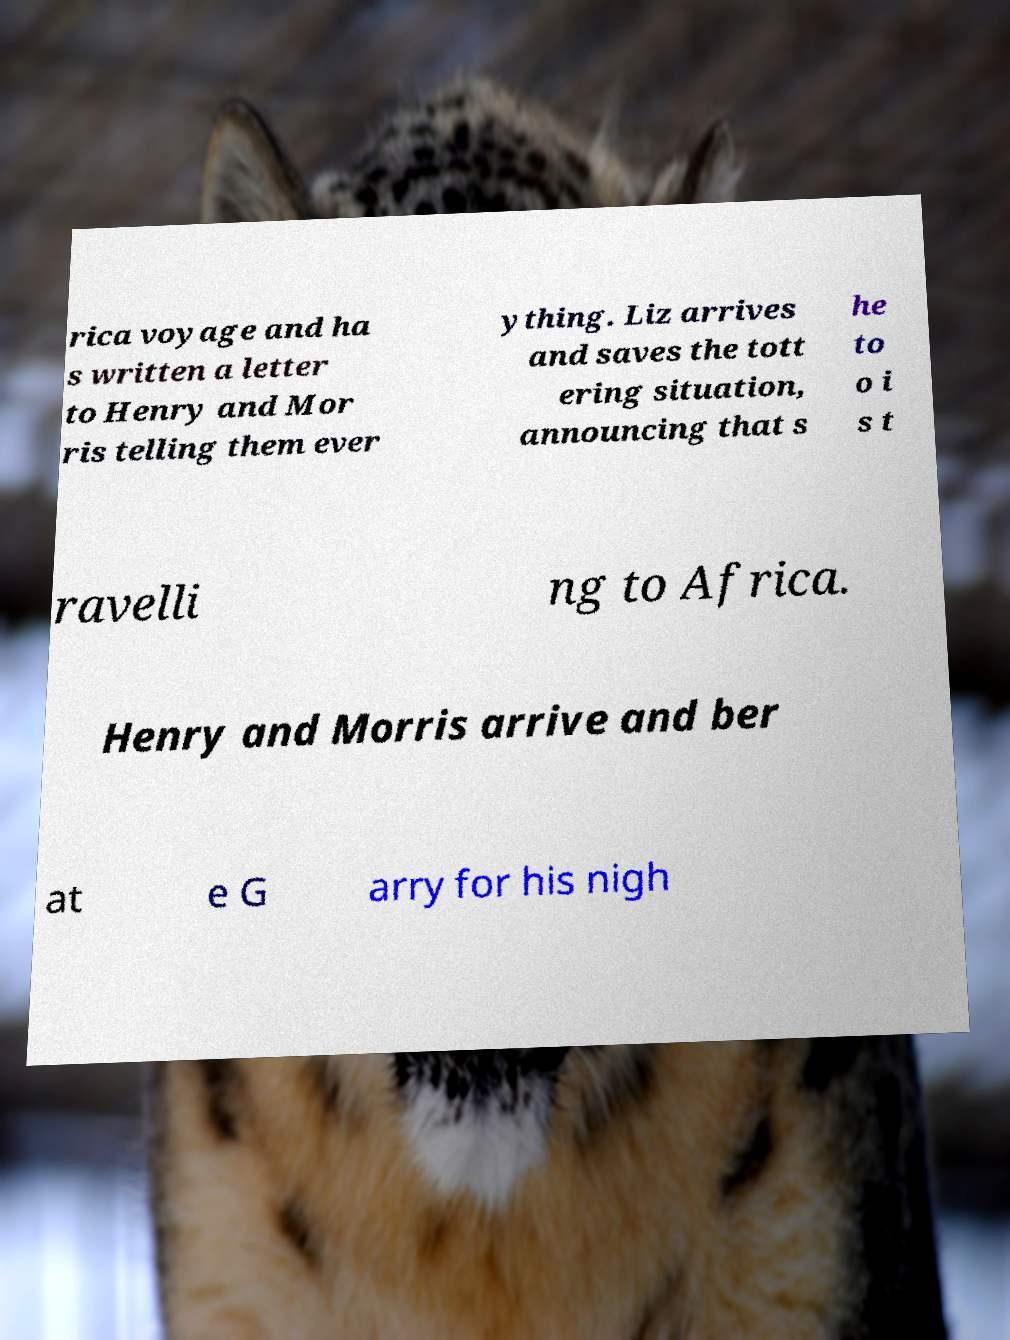I need the written content from this picture converted into text. Can you do that? rica voyage and ha s written a letter to Henry and Mor ris telling them ever ything. Liz arrives and saves the tott ering situation, announcing that s he to o i s t ravelli ng to Africa. Henry and Morris arrive and ber at e G arry for his nigh 